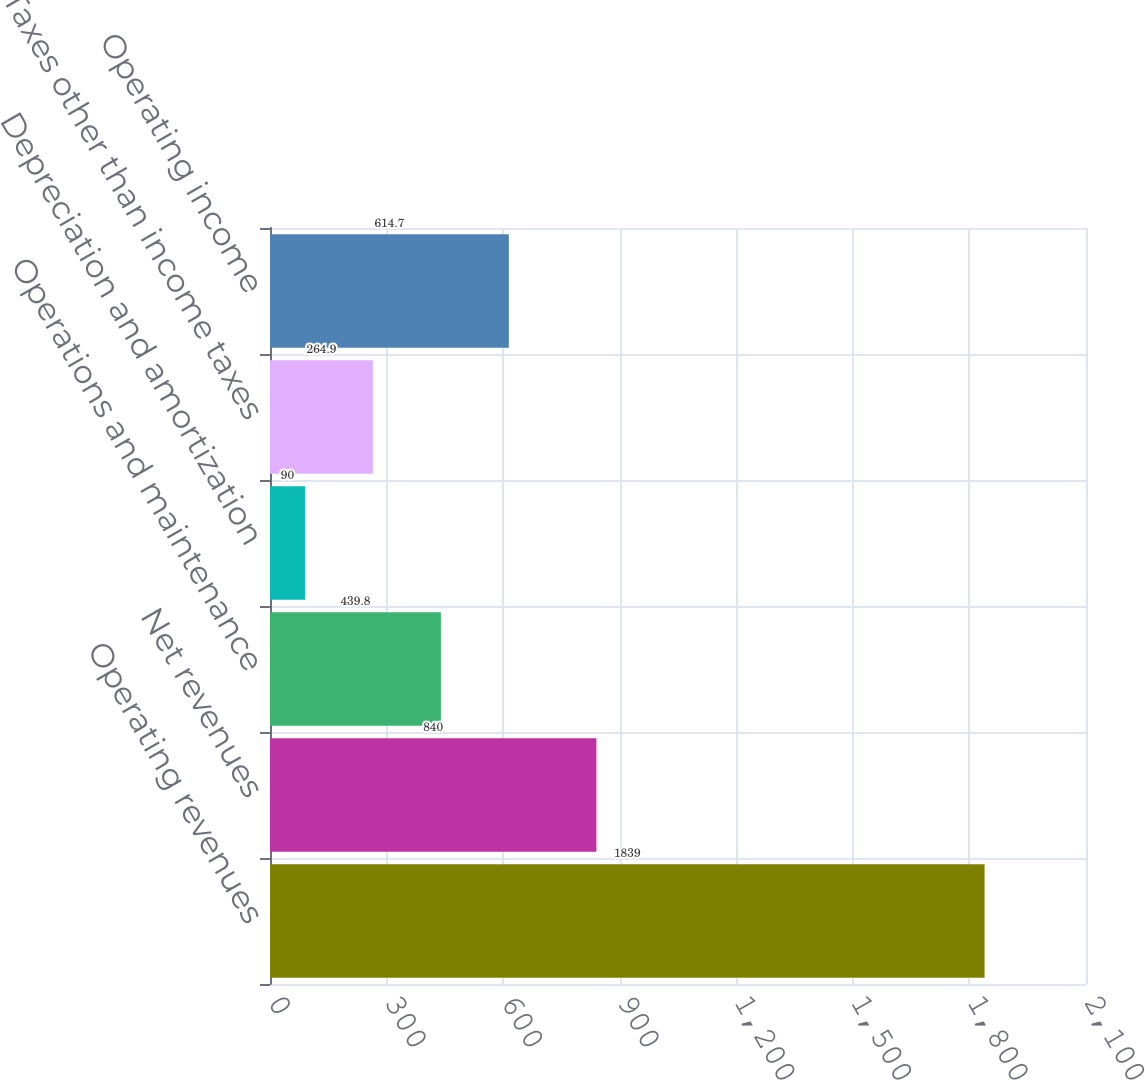<chart> <loc_0><loc_0><loc_500><loc_500><bar_chart><fcel>Operating revenues<fcel>Net revenues<fcel>Operations and maintenance<fcel>Depreciation and amortization<fcel>Taxes other than income taxes<fcel>Operating income<nl><fcel>1839<fcel>840<fcel>439.8<fcel>90<fcel>264.9<fcel>614.7<nl></chart> 